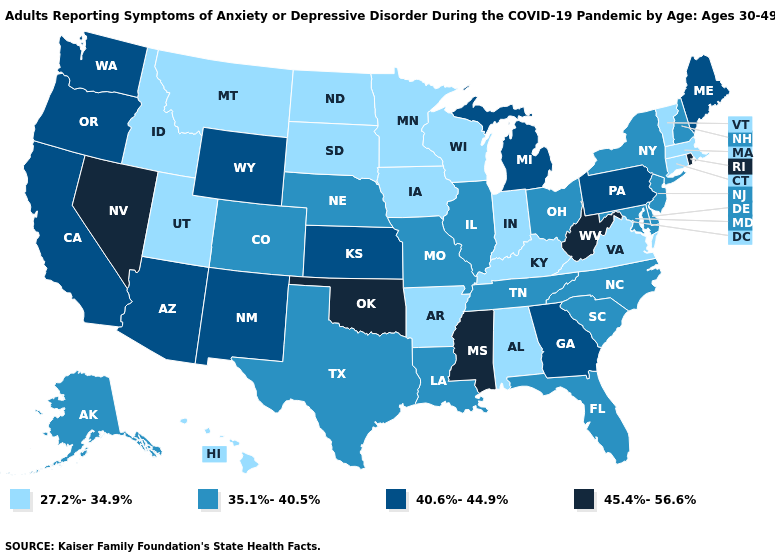What is the lowest value in the MidWest?
Concise answer only. 27.2%-34.9%. Which states have the lowest value in the USA?
Short answer required. Alabama, Arkansas, Connecticut, Hawaii, Idaho, Indiana, Iowa, Kentucky, Massachusetts, Minnesota, Montana, North Dakota, South Dakota, Utah, Vermont, Virginia, Wisconsin. Does New Jersey have a higher value than Colorado?
Answer briefly. No. Among the states that border Kentucky , which have the highest value?
Concise answer only. West Virginia. Among the states that border West Virginia , does Kentucky have the lowest value?
Concise answer only. Yes. Name the states that have a value in the range 40.6%-44.9%?
Write a very short answer. Arizona, California, Georgia, Kansas, Maine, Michigan, New Mexico, Oregon, Pennsylvania, Washington, Wyoming. Which states have the highest value in the USA?
Answer briefly. Mississippi, Nevada, Oklahoma, Rhode Island, West Virginia. Does Alaska have a lower value than Wyoming?
Answer briefly. Yes. Among the states that border Nebraska , which have the lowest value?
Short answer required. Iowa, South Dakota. What is the lowest value in states that border Ohio?
Short answer required. 27.2%-34.9%. Name the states that have a value in the range 45.4%-56.6%?
Be succinct. Mississippi, Nevada, Oklahoma, Rhode Island, West Virginia. What is the value of Minnesota?
Be succinct. 27.2%-34.9%. Which states have the highest value in the USA?
Write a very short answer. Mississippi, Nevada, Oklahoma, Rhode Island, West Virginia. Name the states that have a value in the range 45.4%-56.6%?
Write a very short answer. Mississippi, Nevada, Oklahoma, Rhode Island, West Virginia. Does the first symbol in the legend represent the smallest category?
Be succinct. Yes. 